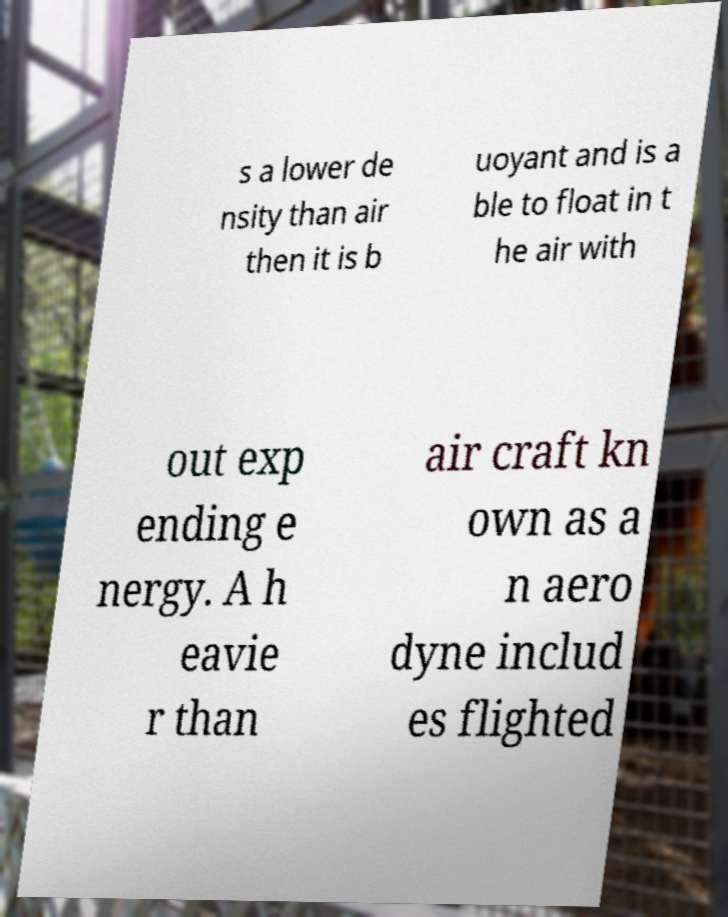There's text embedded in this image that I need extracted. Can you transcribe it verbatim? s a lower de nsity than air then it is b uoyant and is a ble to float in t he air with out exp ending e nergy. A h eavie r than air craft kn own as a n aero dyne includ es flighted 